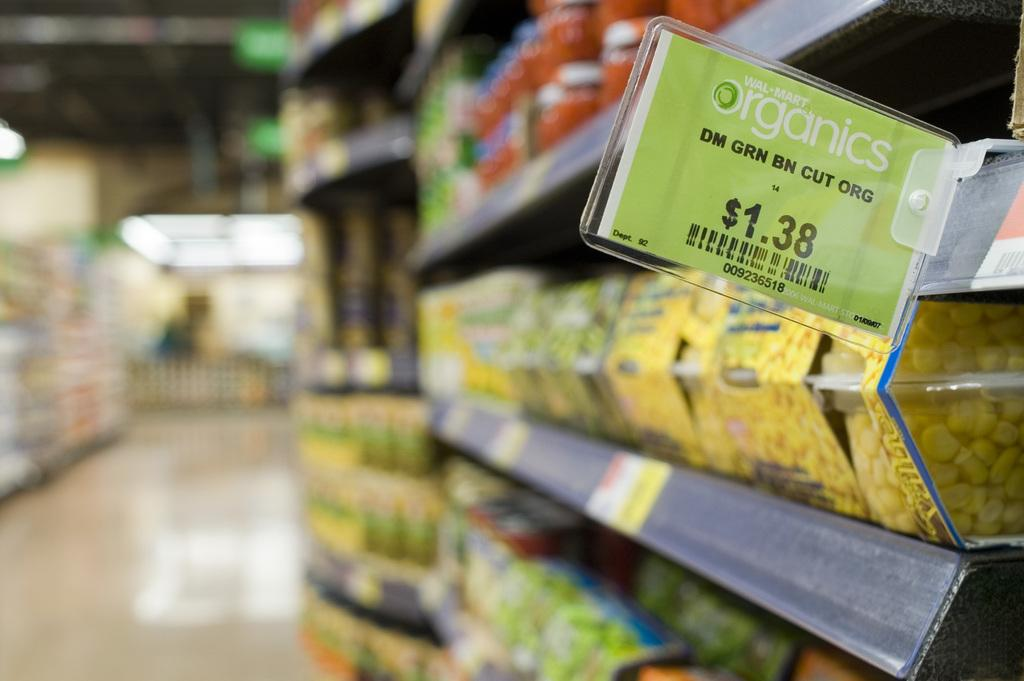<image>
Give a short and clear explanation of the subsequent image. An aisle of an organics supermarket with packaged corn being sold in a plastic case. 